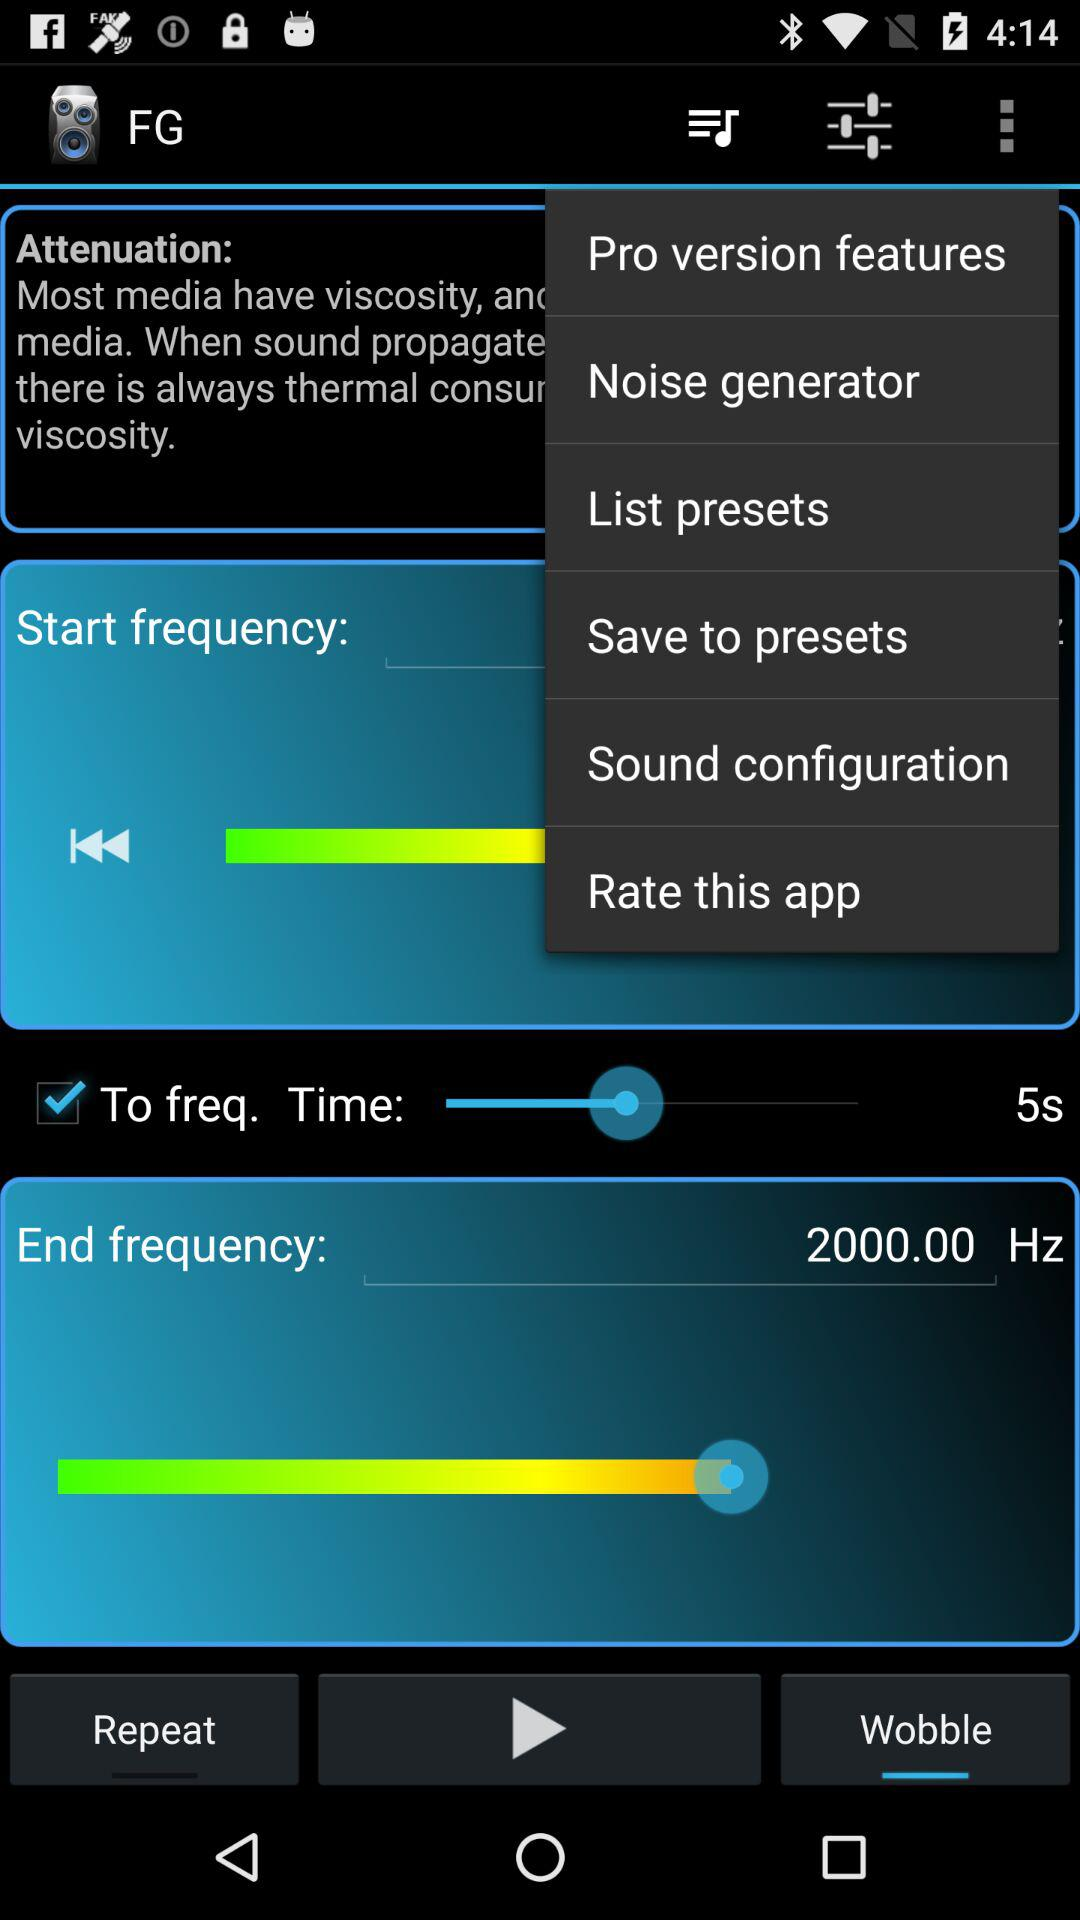What is the application name? The application name is "FG". 